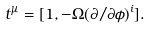<formula> <loc_0><loc_0><loc_500><loc_500>t ^ { \mu } = [ 1 , - \Omega ( \partial / \partial \phi ) ^ { i } ] .</formula> 